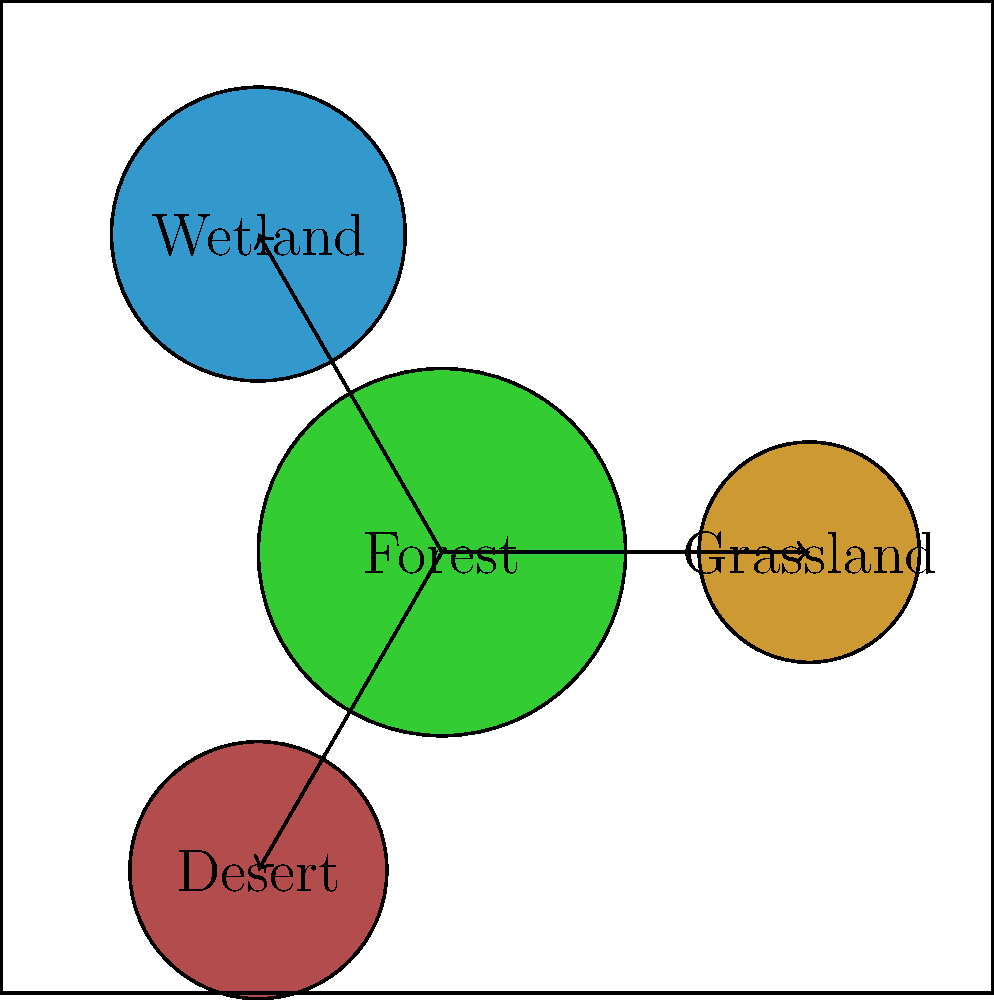Consider the surface representation of interconnected ecosystems shown above. What is the genus of this surface, and how does it relate to the ecological concept of ecosystem connectivity? To determine the genus of this surface and relate it to ecosystem connectivity, let's follow these steps:

1. Identify the surface topology:
   The diagram shows four interconnected ecosystems (Forest, Grassland, Wetland, and Desert) represented as circular regions with arrows indicating connections.

2. Count the number of holes:
   In topology, the genus of a surface is the number of holes or "handles" it has. In this representation, there are no visible holes.

3. Calculate the genus:
   The genus of this surface is 0, as it has no holes. This is topologically equivalent to a sphere.

4. Relate to ecosystem connectivity:
   The arrows between ecosystems represent ecological connections or interactions. These connections do not create topological holes but rather indicate the flow of energy, nutrients, or species between ecosystems.

5. Interpret the ecological significance:
   - A genus-0 surface (sphere-like) suggests that all ecosystems are interconnected without creating isolated regions.
   - The lack of holes implies that there are no "shortcuts" or alternative pathways between ecosystems that bypass others.
   - This representation emphasizes the importance of considering all ecosystem interactions holistically, as changes in one ecosystem can potentially affect all others through direct or indirect connections.

6. Consider limitations:
   While this representation is useful for visualizing ecosystem connectivity, it's important to note that real ecosystems have more complex interactions that may not be fully captured by a genus-0 surface. More complex topological representations might be needed for more detailed ecological models.
Answer: Genus 0; represents fully interconnected ecosystems without isolated regions or alternative pathways. 